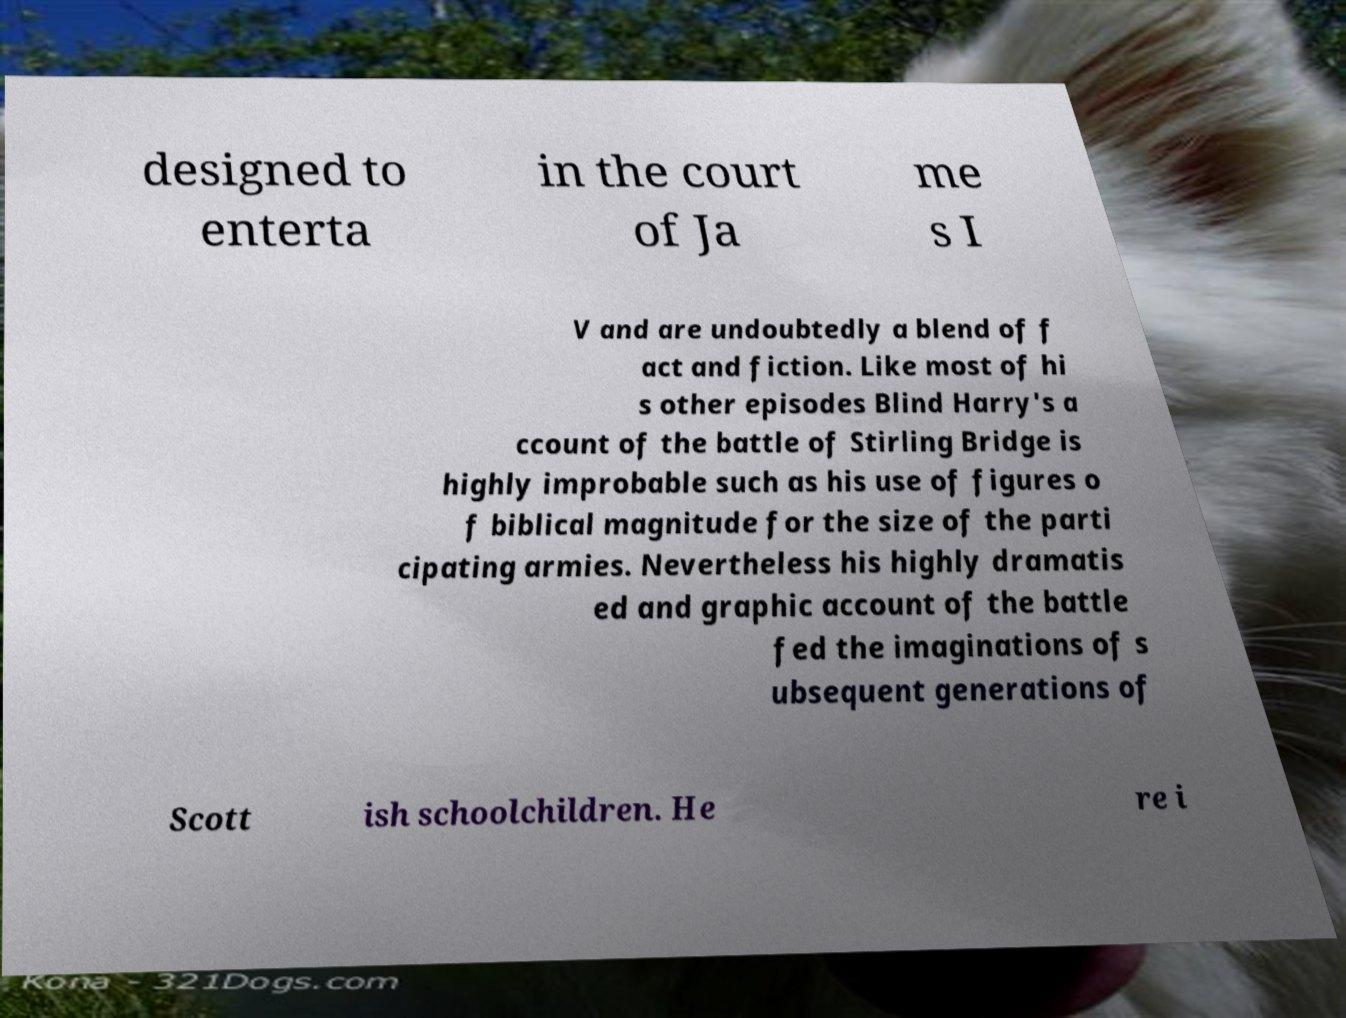Please identify and transcribe the text found in this image. designed to enterta in the court of Ja me s I V and are undoubtedly a blend of f act and fiction. Like most of hi s other episodes Blind Harry's a ccount of the battle of Stirling Bridge is highly improbable such as his use of figures o f biblical magnitude for the size of the parti cipating armies. Nevertheless his highly dramatis ed and graphic account of the battle fed the imaginations of s ubsequent generations of Scott ish schoolchildren. He re i 